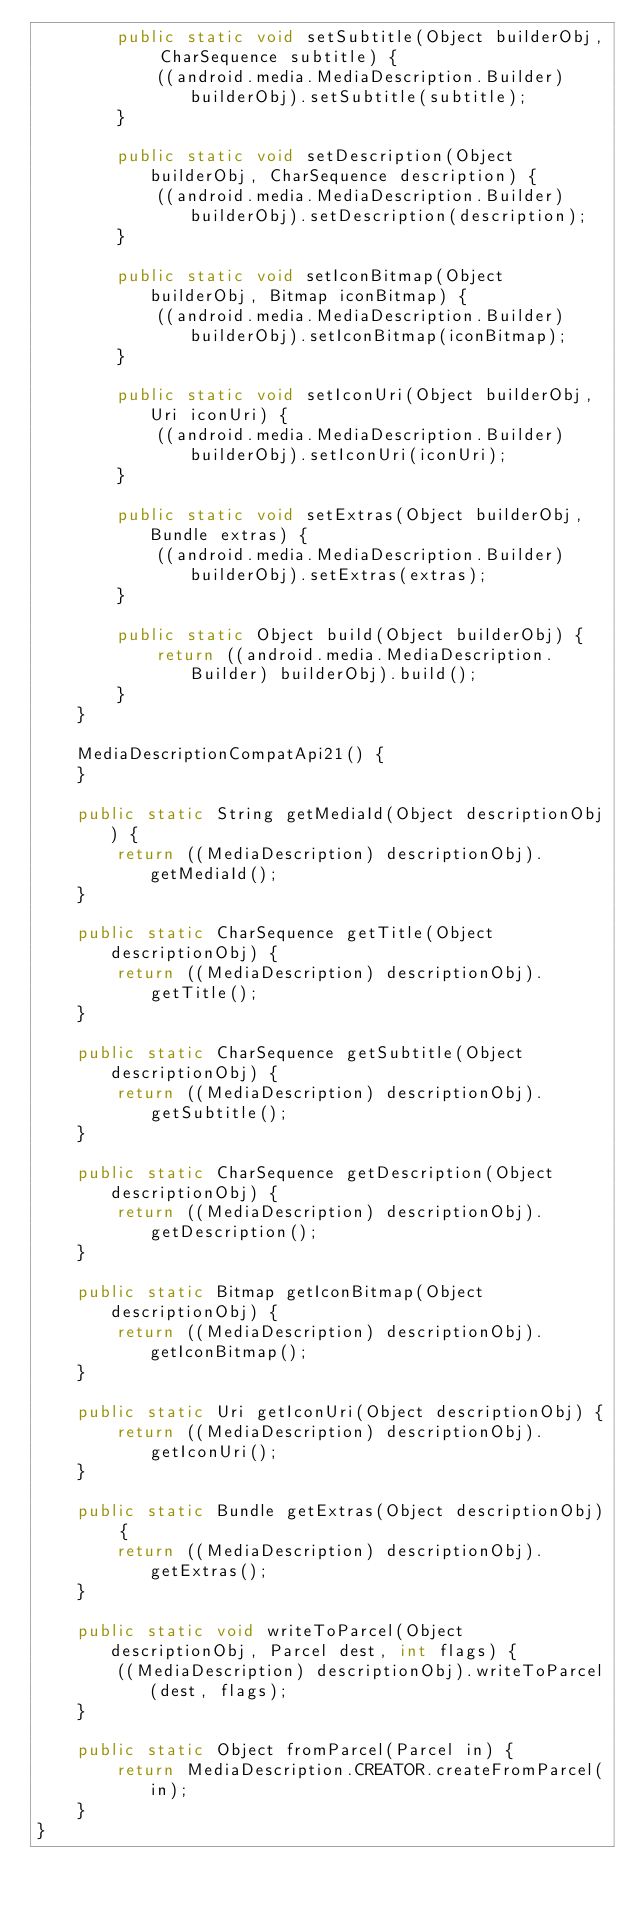Convert code to text. <code><loc_0><loc_0><loc_500><loc_500><_Java_>        public static void setSubtitle(Object builderObj, CharSequence subtitle) {
            ((android.media.MediaDescription.Builder) builderObj).setSubtitle(subtitle);
        }

        public static void setDescription(Object builderObj, CharSequence description) {
            ((android.media.MediaDescription.Builder) builderObj).setDescription(description);
        }

        public static void setIconBitmap(Object builderObj, Bitmap iconBitmap) {
            ((android.media.MediaDescription.Builder) builderObj).setIconBitmap(iconBitmap);
        }

        public static void setIconUri(Object builderObj, Uri iconUri) {
            ((android.media.MediaDescription.Builder) builderObj).setIconUri(iconUri);
        }

        public static void setExtras(Object builderObj, Bundle extras) {
            ((android.media.MediaDescription.Builder) builderObj).setExtras(extras);
        }

        public static Object build(Object builderObj) {
            return ((android.media.MediaDescription.Builder) builderObj).build();
        }
    }

    MediaDescriptionCompatApi21() {
    }

    public static String getMediaId(Object descriptionObj) {
        return ((MediaDescription) descriptionObj).getMediaId();
    }

    public static CharSequence getTitle(Object descriptionObj) {
        return ((MediaDescription) descriptionObj).getTitle();
    }

    public static CharSequence getSubtitle(Object descriptionObj) {
        return ((MediaDescription) descriptionObj).getSubtitle();
    }

    public static CharSequence getDescription(Object descriptionObj) {
        return ((MediaDescription) descriptionObj).getDescription();
    }

    public static Bitmap getIconBitmap(Object descriptionObj) {
        return ((MediaDescription) descriptionObj).getIconBitmap();
    }

    public static Uri getIconUri(Object descriptionObj) {
        return ((MediaDescription) descriptionObj).getIconUri();
    }

    public static Bundle getExtras(Object descriptionObj) {
        return ((MediaDescription) descriptionObj).getExtras();
    }

    public static void writeToParcel(Object descriptionObj, Parcel dest, int flags) {
        ((MediaDescription) descriptionObj).writeToParcel(dest, flags);
    }

    public static Object fromParcel(Parcel in) {
        return MediaDescription.CREATOR.createFromParcel(in);
    }
}
</code> 